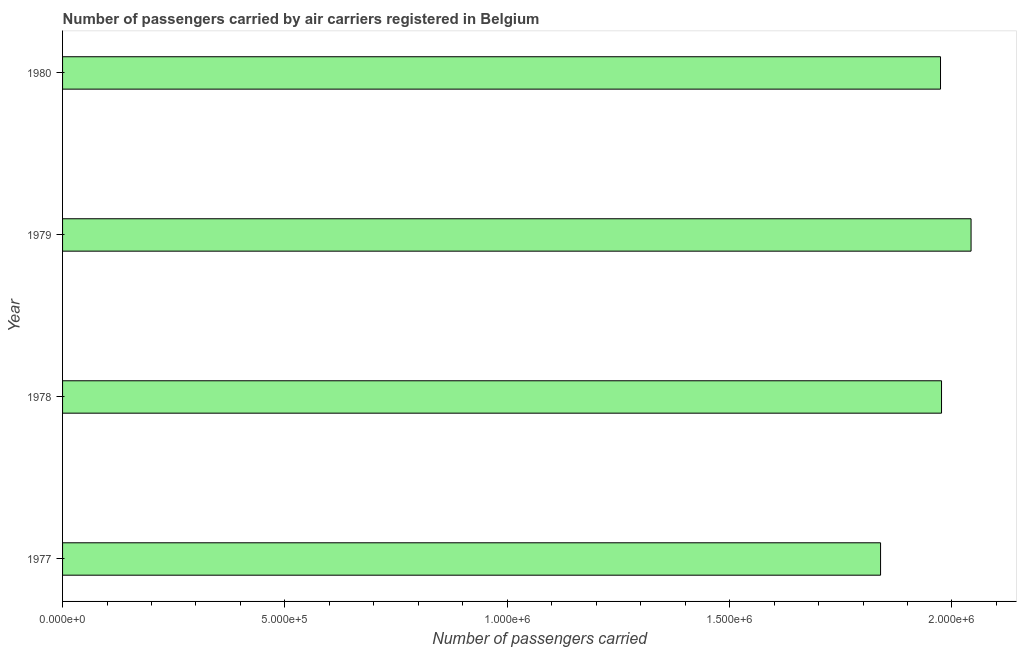Does the graph contain grids?
Ensure brevity in your answer.  No. What is the title of the graph?
Provide a short and direct response. Number of passengers carried by air carriers registered in Belgium. What is the label or title of the X-axis?
Your response must be concise. Number of passengers carried. What is the number of passengers carried in 1978?
Make the answer very short. 1.98e+06. Across all years, what is the maximum number of passengers carried?
Your answer should be compact. 2.04e+06. Across all years, what is the minimum number of passengers carried?
Provide a succinct answer. 1.84e+06. In which year was the number of passengers carried maximum?
Provide a succinct answer. 1979. What is the sum of the number of passengers carried?
Make the answer very short. 7.83e+06. What is the difference between the number of passengers carried in 1977 and 1979?
Offer a terse response. -2.04e+05. What is the average number of passengers carried per year?
Your answer should be very brief. 1.96e+06. What is the median number of passengers carried?
Provide a short and direct response. 1.98e+06. Is the difference between the number of passengers carried in 1977 and 1979 greater than the difference between any two years?
Make the answer very short. Yes. What is the difference between the highest and the second highest number of passengers carried?
Provide a short and direct response. 6.64e+04. What is the difference between the highest and the lowest number of passengers carried?
Your answer should be very brief. 2.04e+05. How many years are there in the graph?
Offer a very short reply. 4. What is the Number of passengers carried in 1977?
Your answer should be very brief. 1.84e+06. What is the Number of passengers carried in 1978?
Offer a terse response. 1.98e+06. What is the Number of passengers carried of 1979?
Your response must be concise. 2.04e+06. What is the Number of passengers carried of 1980?
Make the answer very short. 1.97e+06. What is the difference between the Number of passengers carried in 1977 and 1978?
Your answer should be compact. -1.37e+05. What is the difference between the Number of passengers carried in 1977 and 1979?
Your answer should be very brief. -2.04e+05. What is the difference between the Number of passengers carried in 1977 and 1980?
Your response must be concise. -1.35e+05. What is the difference between the Number of passengers carried in 1978 and 1979?
Offer a very short reply. -6.64e+04. What is the difference between the Number of passengers carried in 1978 and 1980?
Give a very brief answer. 2300. What is the difference between the Number of passengers carried in 1979 and 1980?
Provide a succinct answer. 6.87e+04. What is the ratio of the Number of passengers carried in 1977 to that in 1980?
Provide a short and direct response. 0.93. What is the ratio of the Number of passengers carried in 1978 to that in 1980?
Offer a terse response. 1. What is the ratio of the Number of passengers carried in 1979 to that in 1980?
Give a very brief answer. 1.03. 